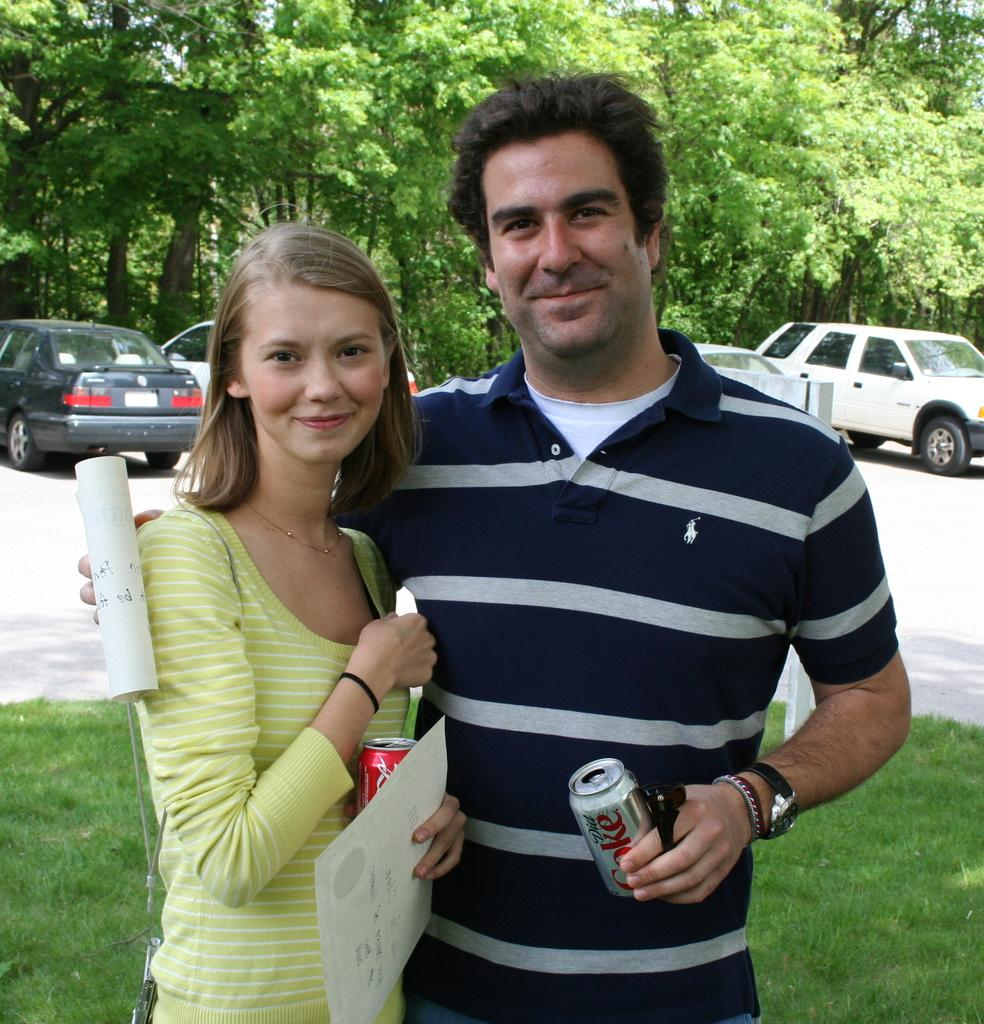How many people are present in the image? There are two people, a man and a woman, present in the image. What are the expressions on their faces? Both the man and woman are smiling in the image. What objects are the man and woman holding? The man and woman are holding tins and papers in the image. What can be seen in the background of the image? There are cars and trees in the background of the image. What type of texture can be seen on the hall in the image? There is no hall present in the image, so it is not possible to determine the texture of any such surface. 